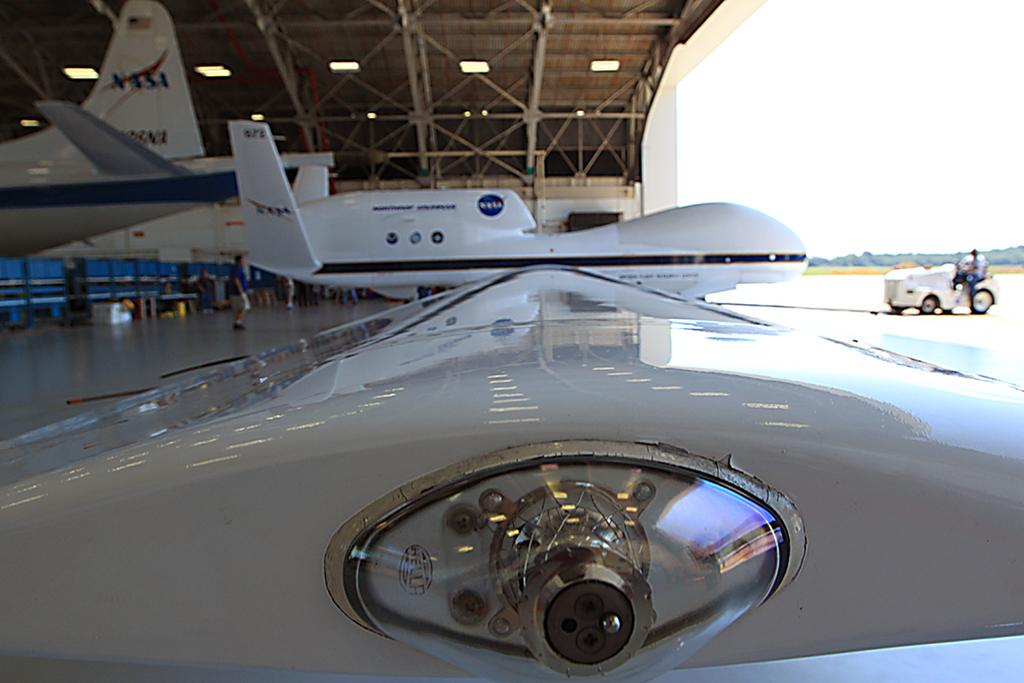<image>
Present a compact description of the photo's key features. a large plane with the NASA logo on it 